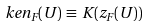<formula> <loc_0><loc_0><loc_500><loc_500>\ k e n _ { F } ( U ) \, \equiv \, K ( z _ { F } ( U ) )</formula> 